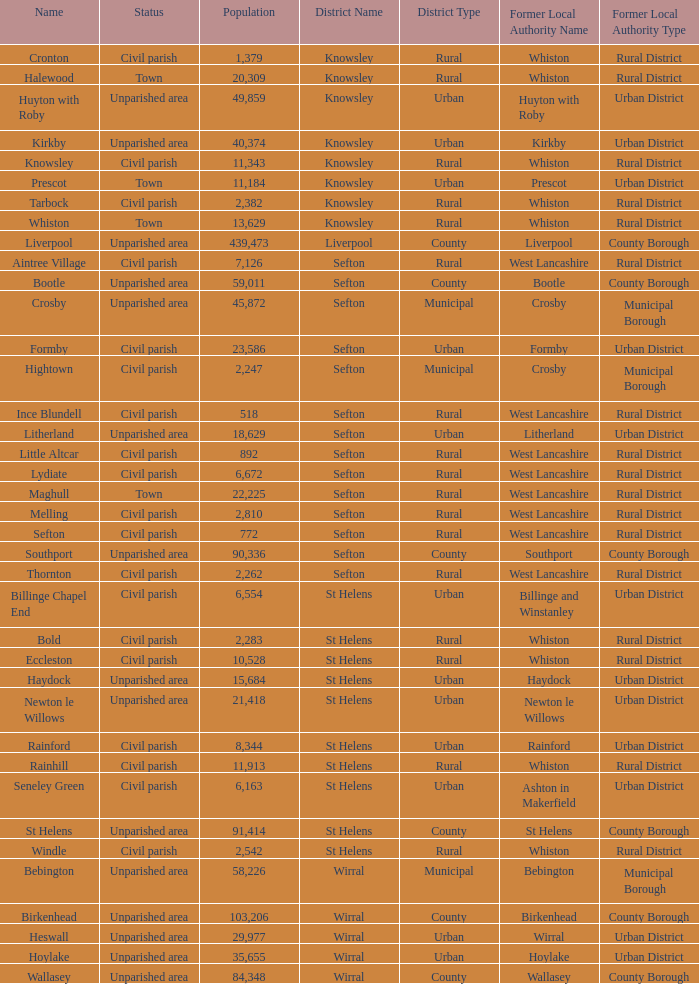What is the district of wallasey Wirral. 